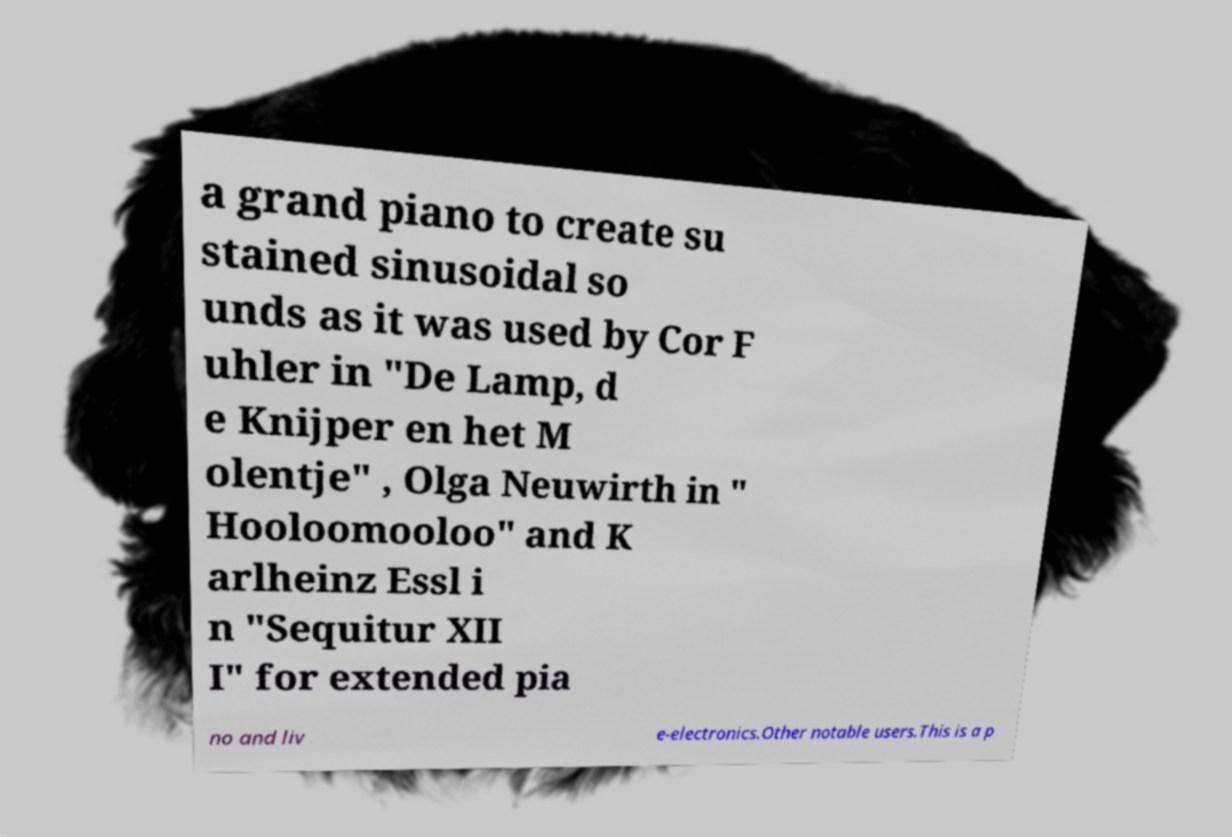Could you assist in decoding the text presented in this image and type it out clearly? a grand piano to create su stained sinusoidal so unds as it was used by Cor F uhler in "De Lamp, d e Knijper en het M olentje" , Olga Neuwirth in " Hooloomooloo" and K arlheinz Essl i n "Sequitur XII I" for extended pia no and liv e-electronics.Other notable users.This is a p 